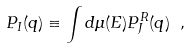Convert formula to latex. <formula><loc_0><loc_0><loc_500><loc_500>P _ { I } ( { q } ) \equiv \int d \mu ( E ) P _ { J } ^ { R } ( { q } ) \ ,</formula> 